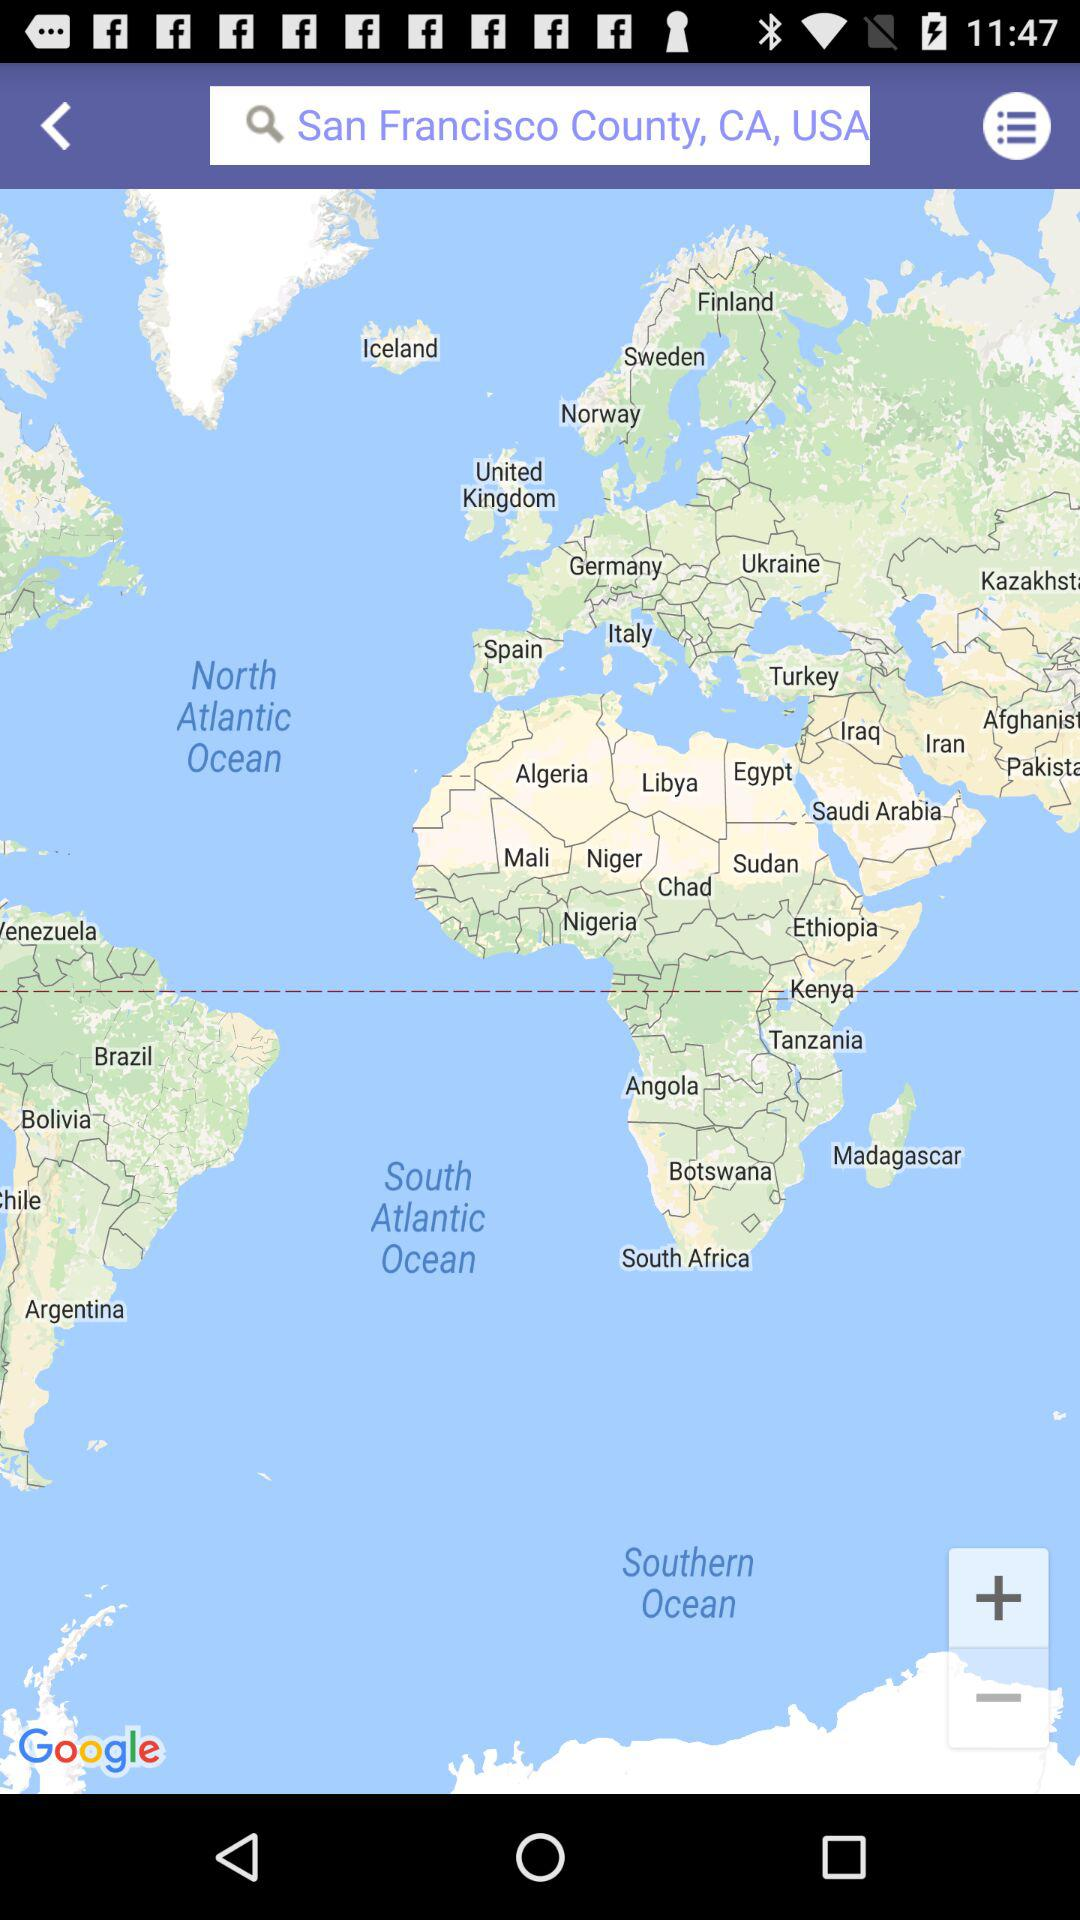What is the location in the search bar? The location in the search bar is San Francisco County, CA, USA. 